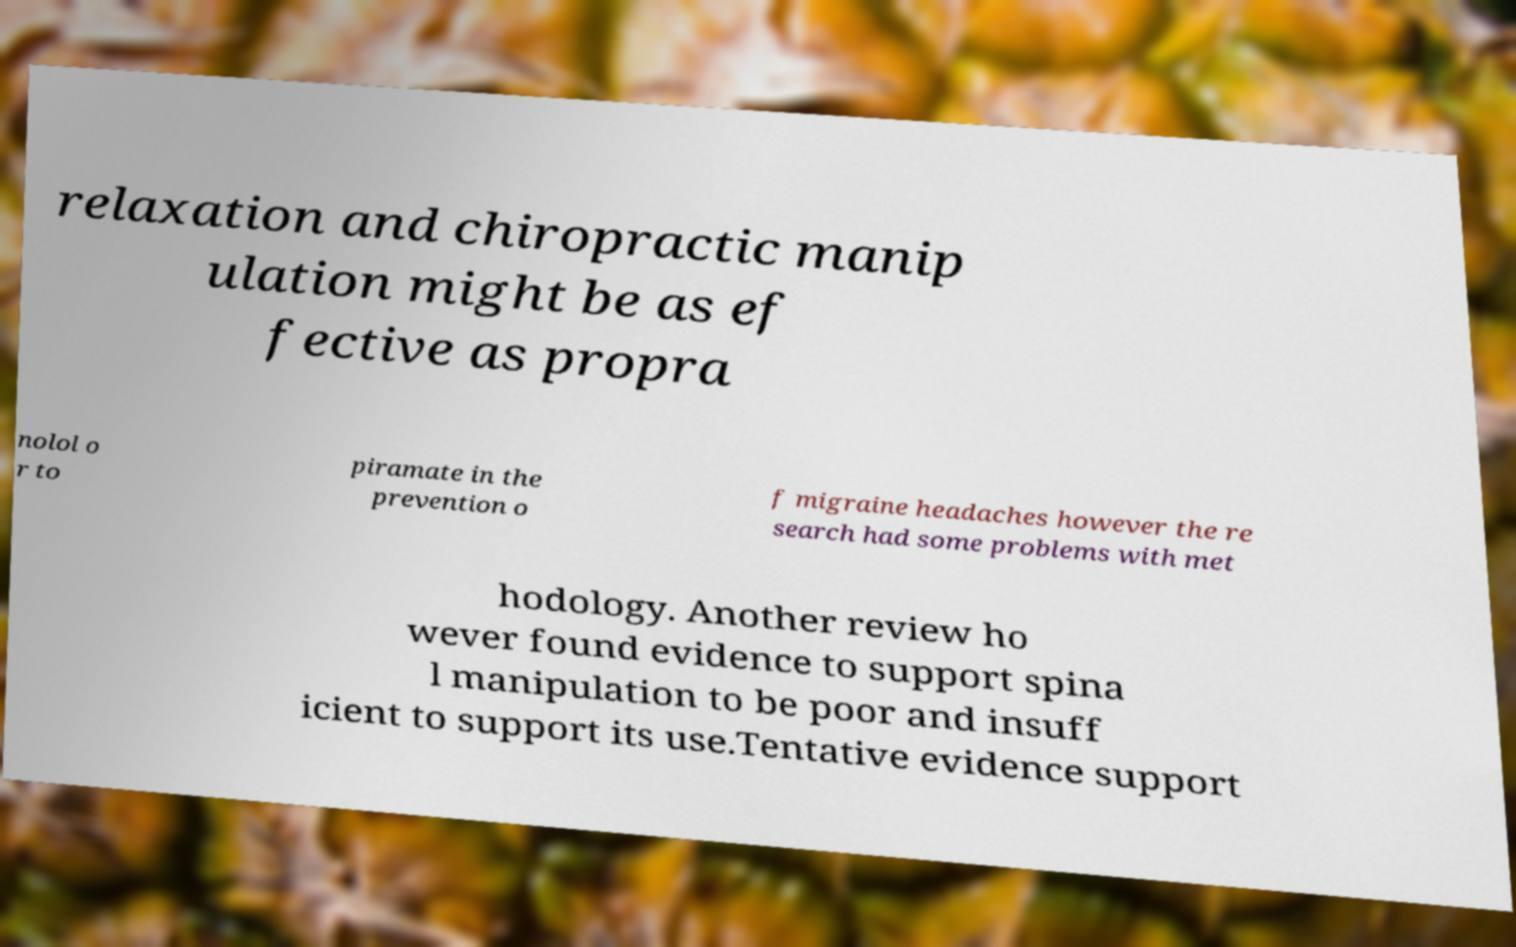Could you extract and type out the text from this image? relaxation and chiropractic manip ulation might be as ef fective as propra nolol o r to piramate in the prevention o f migraine headaches however the re search had some problems with met hodology. Another review ho wever found evidence to support spina l manipulation to be poor and insuff icient to support its use.Tentative evidence support 